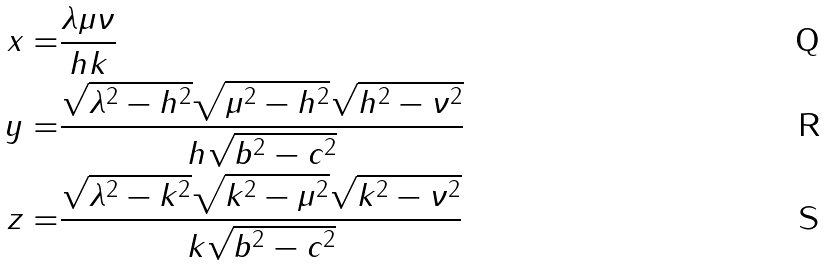<formula> <loc_0><loc_0><loc_500><loc_500>x = & \frac { \lambda \mu \nu } { h k } \\ y = & \frac { \sqrt { \lambda ^ { 2 } - h ^ { 2 } } \sqrt { \mu ^ { 2 } - h ^ { 2 } } \sqrt { h ^ { 2 } - \nu ^ { 2 } } } { h \sqrt { b ^ { 2 } - c ^ { 2 } } } \\ z = & \frac { \sqrt { \lambda ^ { 2 } - k ^ { 2 } } \sqrt { k ^ { 2 } - \mu ^ { 2 } } \sqrt { k ^ { 2 } - \nu ^ { 2 } } } { k \sqrt { b ^ { 2 } - c ^ { 2 } } }</formula> 